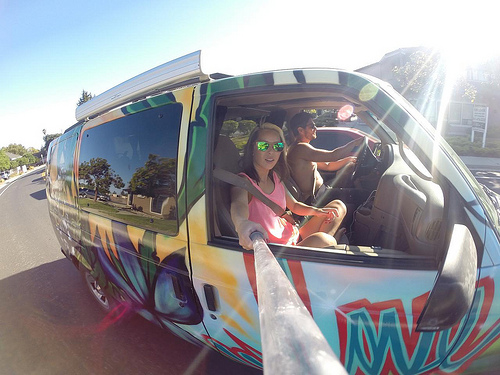<image>
Is there a girl next to the car? No. The girl is not positioned next to the car. They are located in different areas of the scene. 